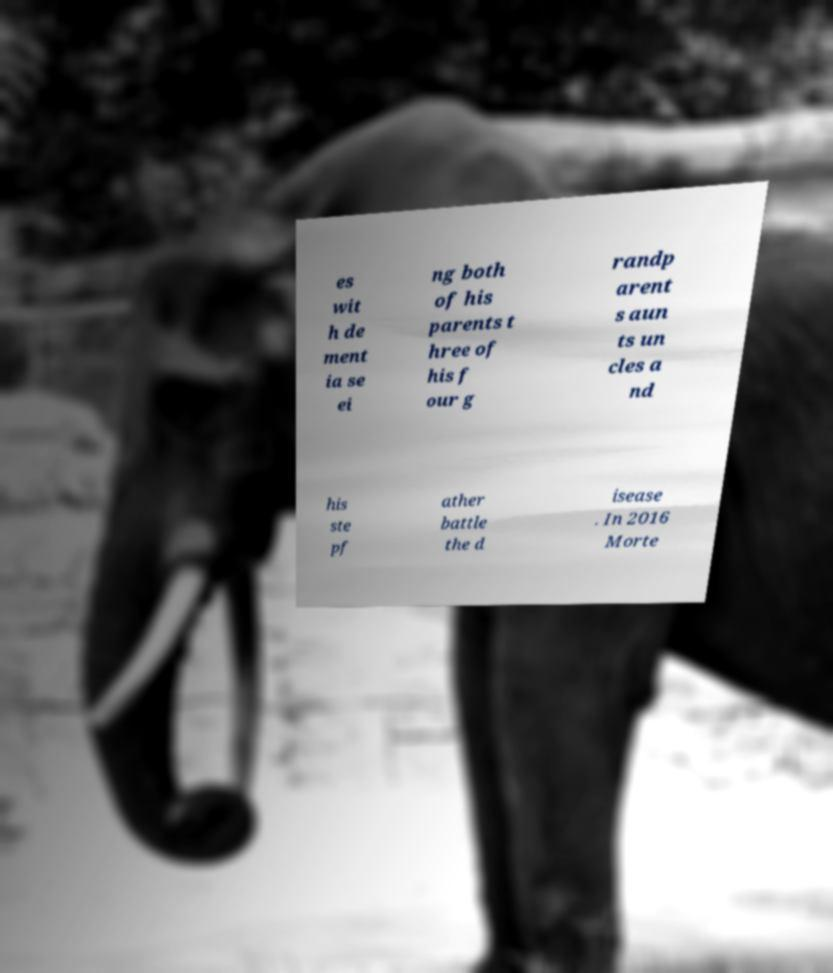There's text embedded in this image that I need extracted. Can you transcribe it verbatim? es wit h de ment ia se ei ng both of his parents t hree of his f our g randp arent s aun ts un cles a nd his ste pf ather battle the d isease . In 2016 Morte 